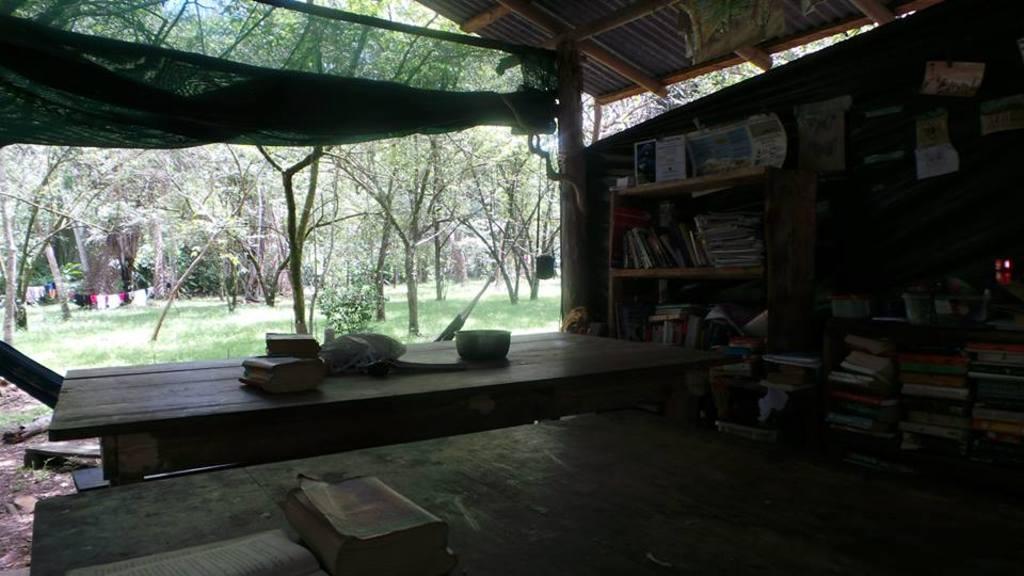Can you describe this image briefly? This image is taken in outdoors. In this image there is a table, a net. In the middle of the image there is a table and there were few things on it. In the left side of the image there is a ground with grass. In the right side of the image there is a shelves in which books were placed. At the top of the image there is a roof. At the background there were many trees and plants. 